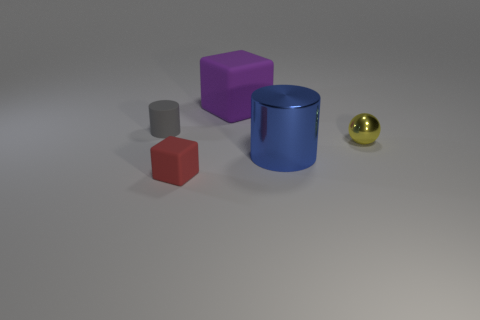Is there any other thing that is made of the same material as the small gray object?
Keep it short and to the point. Yes. The other thing that is the same shape as the purple thing is what size?
Provide a short and direct response. Small. What is the material of the large object behind the yellow ball?
Offer a terse response. Rubber. Is the number of blue shiny cylinders behind the small ball less than the number of metal cylinders?
Your response must be concise. Yes. What is the shape of the matte object that is on the left side of the block that is in front of the purple object?
Provide a succinct answer. Cylinder. The big metal thing has what color?
Provide a short and direct response. Blue. What number of other things are there of the same size as the blue shiny cylinder?
Offer a very short reply. 1. The tiny object that is both on the right side of the tiny cylinder and behind the small block is made of what material?
Your answer should be compact. Metal. There is a object that is on the left side of the red object; is its size the same as the big blue object?
Keep it short and to the point. No. Is the tiny matte cylinder the same color as the small rubber block?
Your answer should be very brief. No. 